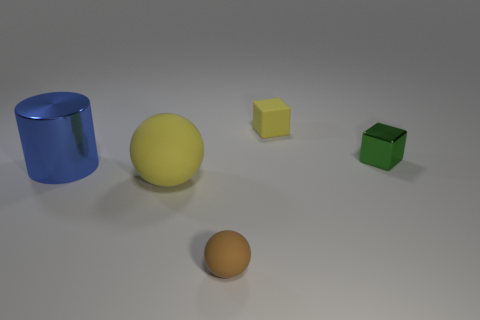Are there any things on the right side of the small rubber object that is on the left side of the tiny rubber thing right of the brown matte sphere?
Make the answer very short. Yes. How many tiny objects are either brown spheres or rubber things?
Make the answer very short. 2. Are there any other things of the same color as the small matte cube?
Offer a very short reply. Yes. There is a yellow thing behind the green thing; is it the same size as the tiny metallic cube?
Offer a very short reply. Yes. What color is the cube in front of the rubber thing that is behind the yellow matte thing that is in front of the large blue cylinder?
Make the answer very short. Green. What color is the large matte object?
Ensure brevity in your answer.  Yellow. Is the small matte cube the same color as the big matte ball?
Provide a short and direct response. Yes. Are the small thing in front of the shiny cylinder and the yellow object on the left side of the brown thing made of the same material?
Your answer should be very brief. Yes. There is another yellow object that is the same shape as the small shiny object; what material is it?
Keep it short and to the point. Rubber. Are the small sphere and the blue object made of the same material?
Your response must be concise. No. 